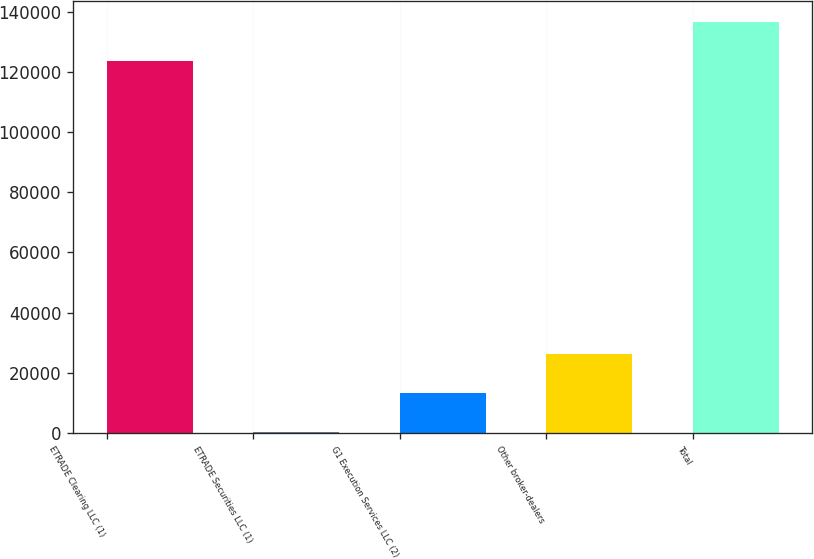Convert chart to OTSL. <chart><loc_0><loc_0><loc_500><loc_500><bar_chart><fcel>ETRADE Clearing LLC (1)<fcel>ETRADE Securities LLC (1)<fcel>G1 Execution Services LLC (2)<fcel>Other broker-dealers<fcel>Total<nl><fcel>123656<fcel>250<fcel>13207.8<fcel>26165.6<fcel>136614<nl></chart> 